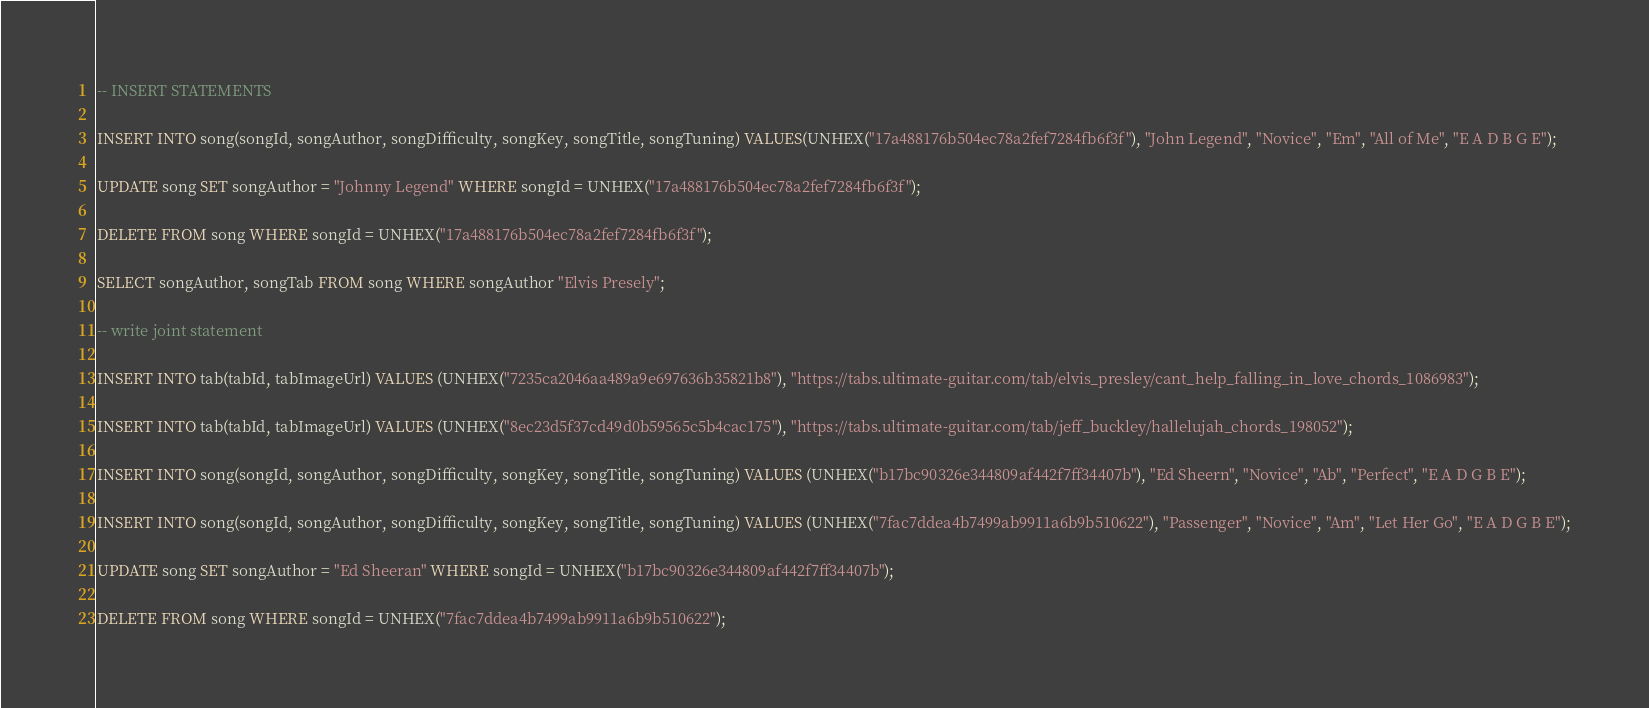Convert code to text. <code><loc_0><loc_0><loc_500><loc_500><_SQL_>-- INSERT STATEMENTS

INSERT INTO song(songId, songAuthor, songDifficulty, songKey, songTitle, songTuning) VALUES(UNHEX("17a488176b504ec78a2fef7284fb6f3f"), "John Legend", "Novice", "Em", "All of Me", "E A D B G E");

UPDATE song SET songAuthor = "Johnny Legend" WHERE songId = UNHEX("17a488176b504ec78a2fef7284fb6f3f");

DELETE FROM song WHERE songId = UNHEX("17a488176b504ec78a2fef7284fb6f3f");

SELECT songAuthor, songTab FROM song WHERE songAuthor "Elvis Presely";

-- write joint statement

INSERT INTO tab(tabId, tabImageUrl) VALUES (UNHEX("7235ca2046aa489a9e697636b35821b8"), "https://tabs.ultimate-guitar.com/tab/elvis_presley/cant_help_falling_in_love_chords_1086983");

INSERT INTO tab(tabId, tabImageUrl) VALUES (UNHEX("8ec23d5f37cd49d0b59565c5b4cac175"), "https://tabs.ultimate-guitar.com/tab/jeff_buckley/hallelujah_chords_198052");

INSERT INTO song(songId, songAuthor, songDifficulty, songKey, songTitle, songTuning) VALUES (UNHEX("b17bc90326e344809af442f7ff34407b"), "Ed Sheern", "Novice", "Ab", "Perfect", "E A D G B E");

INSERT INTO song(songId, songAuthor, songDifficulty, songKey, songTitle, songTuning) VALUES (UNHEX("7fac7ddea4b7499ab9911a6b9b510622"), "Passenger", "Novice", "Am", "Let Her Go", "E A D G B E");

UPDATE song SET songAuthor = "Ed Sheeran" WHERE songId = UNHEX("b17bc90326e344809af442f7ff34407b");

DELETE FROM song WHERE songId = UNHEX("7fac7ddea4b7499ab9911a6b9b510622");</code> 